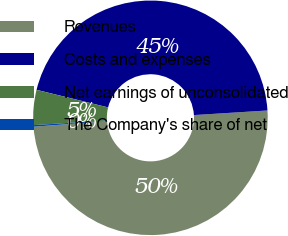Convert chart. <chart><loc_0><loc_0><loc_500><loc_500><pie_chart><fcel>Revenues<fcel>Costs and expenses<fcel>Net earnings of unconsolidated<fcel>The Company's share of net<nl><fcel>49.78%<fcel>45.17%<fcel>4.83%<fcel>0.22%<nl></chart> 